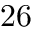Convert formula to latex. <formula><loc_0><loc_0><loc_500><loc_500>2 6</formula> 